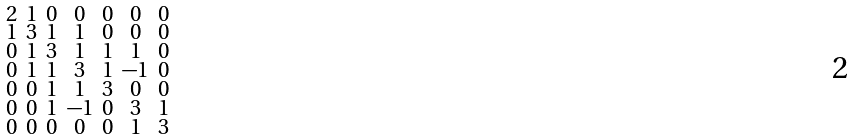Convert formula to latex. <formula><loc_0><loc_0><loc_500><loc_500>\begin{smallmatrix} 2 & 1 & 0 & 0 & 0 & 0 & 0 \\ 1 & 3 & 1 & 1 & 0 & 0 & 0 \\ 0 & 1 & 3 & 1 & 1 & 1 & 0 \\ 0 & 1 & 1 & 3 & 1 & - 1 & 0 \\ 0 & 0 & 1 & 1 & 3 & 0 & 0 \\ 0 & 0 & 1 & - 1 & 0 & 3 & 1 \\ 0 & 0 & 0 & 0 & 0 & 1 & 3 \end{smallmatrix}</formula> 